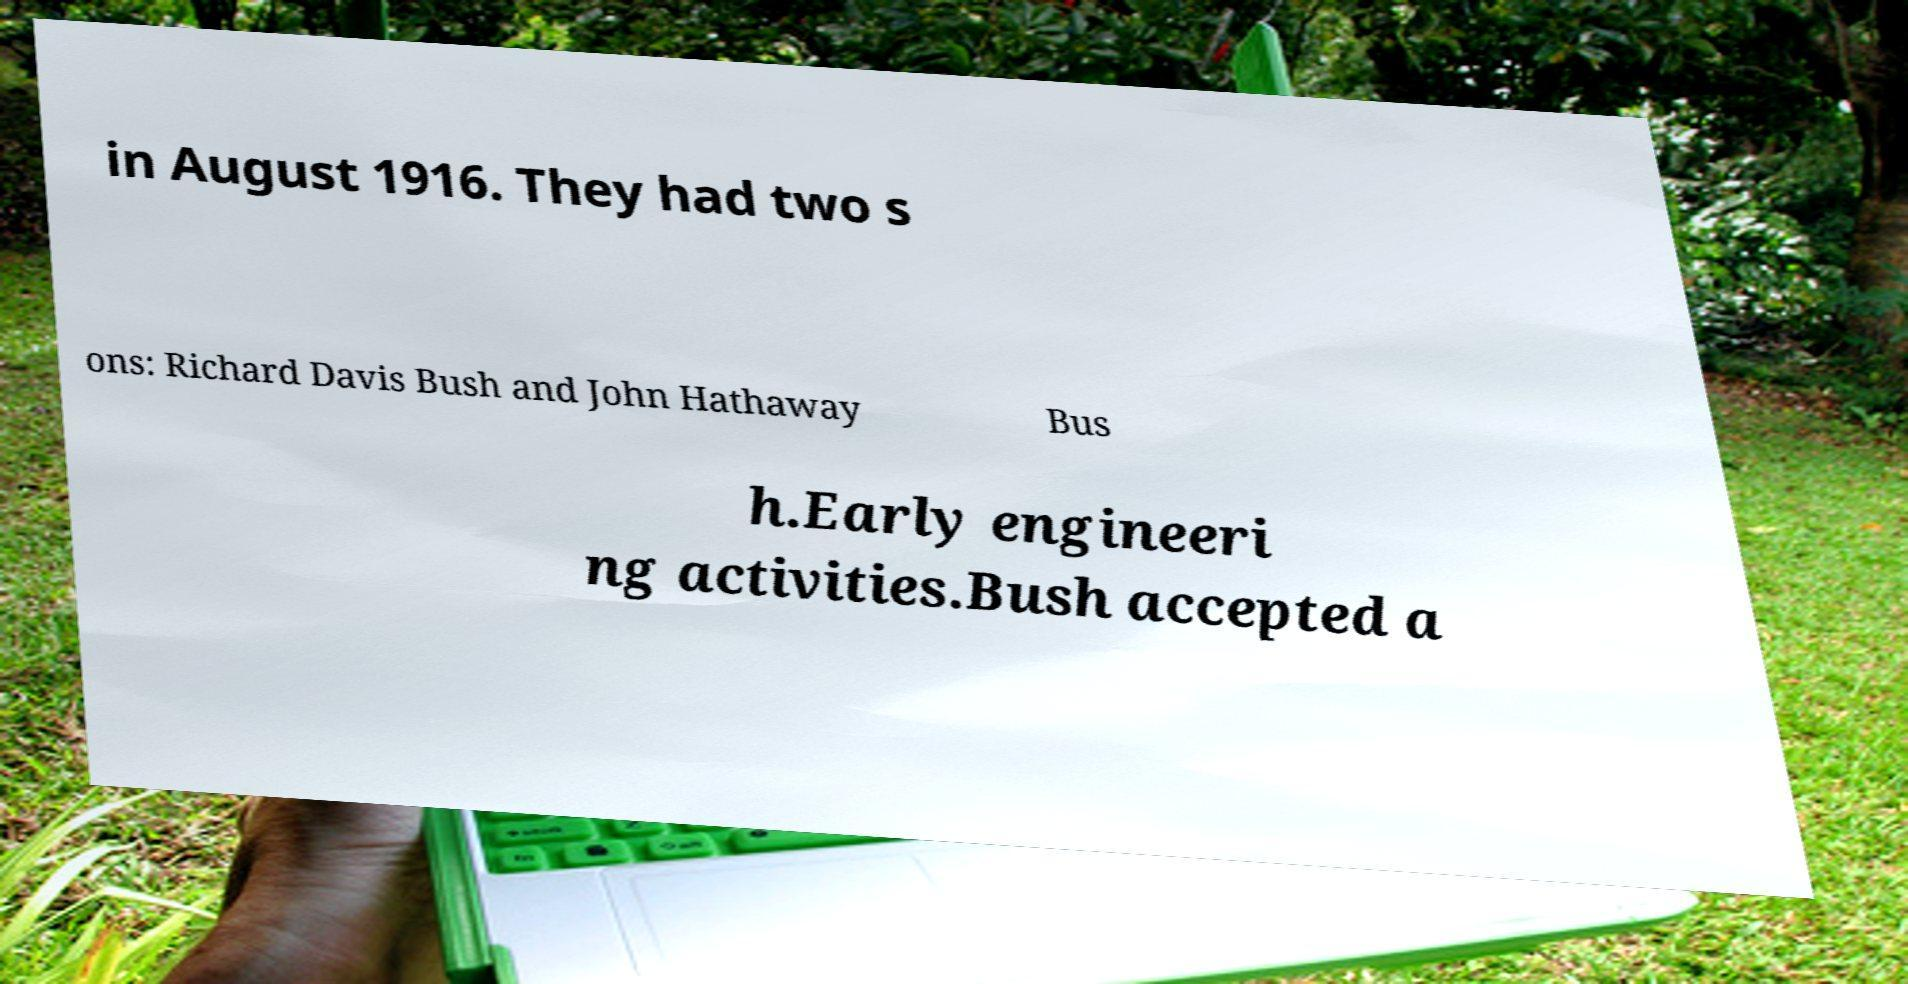I need the written content from this picture converted into text. Can you do that? in August 1916. They had two s ons: Richard Davis Bush and John Hathaway Bus h.Early engineeri ng activities.Bush accepted a 